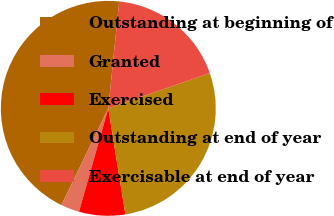Convert chart to OTSL. <chart><loc_0><loc_0><loc_500><loc_500><pie_chart><fcel>Outstanding at beginning of<fcel>Granted<fcel>Exercised<fcel>Outstanding at end of year<fcel>Exercisable at end of year<nl><fcel>44.44%<fcel>2.78%<fcel>6.94%<fcel>27.78%<fcel>18.06%<nl></chart> 